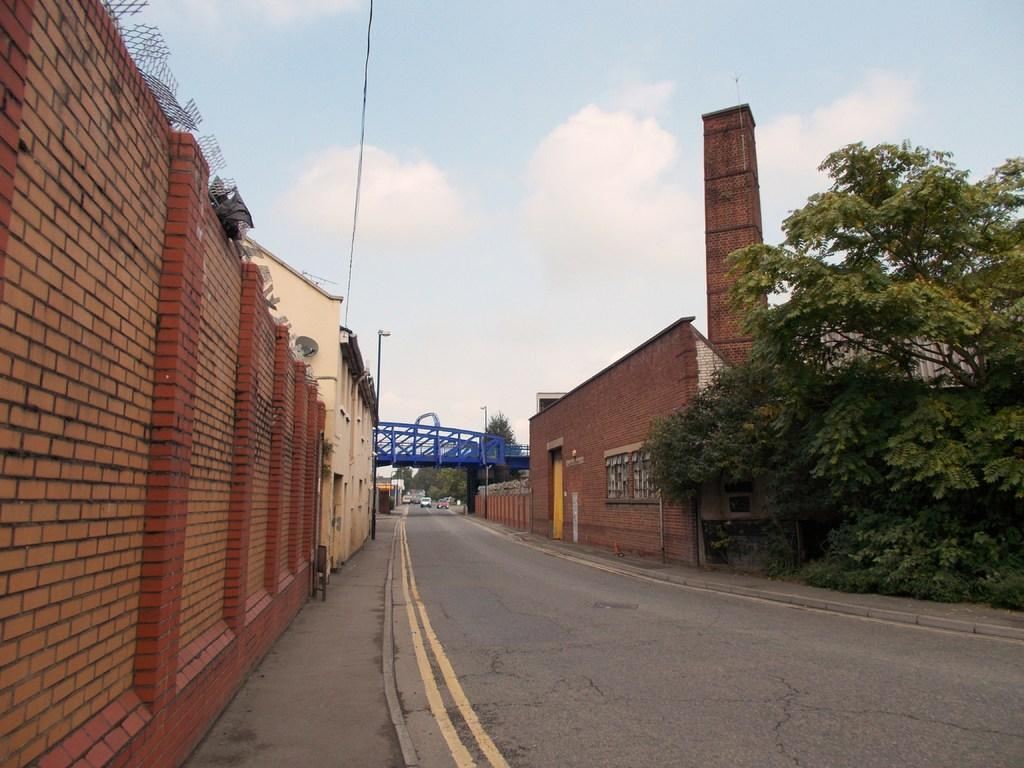What type of structure can be seen in the image? There is a wall in the image. What else can be seen in the image besides the wall? There is a road, wires, buildings, and trees in the image. What is visible in the background of the image? In the background, there is a bridge, trees, and vehicles visible. The sky is also visible in the background. Can you tell me how many times the word "kitty" appears in the image? The word "kitty" does not appear in the image, as it is a visual representation and not a written text. What body part is missing from the image? There is no body part mentioned or implied in the image, as it is a scene of urban infrastructure and not a representation of a living being. 